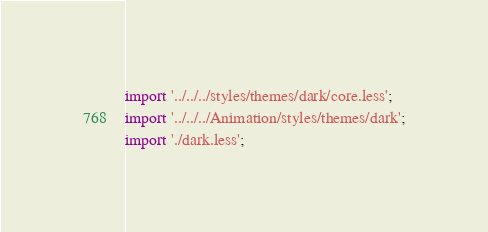Convert code to text. <code><loc_0><loc_0><loc_500><loc_500><_TypeScript_>import '../../../styles/themes/dark/core.less';
import '../../../Animation/styles/themes/dark';
import './dark.less';
</code> 